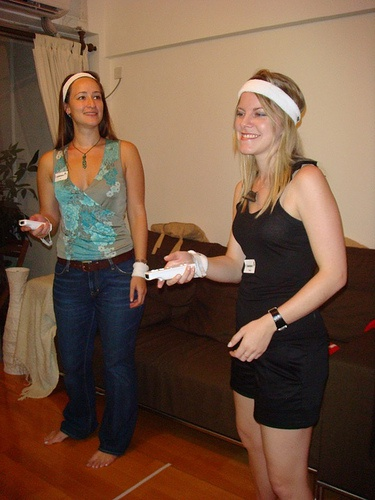Describe the objects in this image and their specific colors. I can see couch in maroon, black, gray, and tan tones, people in maroon, black, tan, and gray tones, people in maroon, black, gray, and brown tones, potted plant in maroon, black, and gray tones, and vase in maroon, gray, and brown tones in this image. 